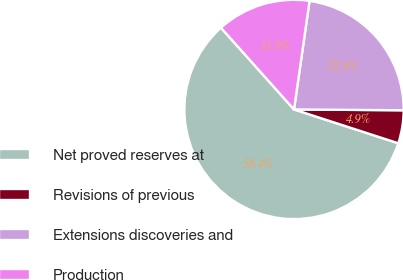<chart> <loc_0><loc_0><loc_500><loc_500><pie_chart><fcel>Net proved reserves at<fcel>Revisions of previous<fcel>Extensions discoveries and<fcel>Production<nl><fcel>58.39%<fcel>4.87%<fcel>22.86%<fcel>13.87%<nl></chart> 